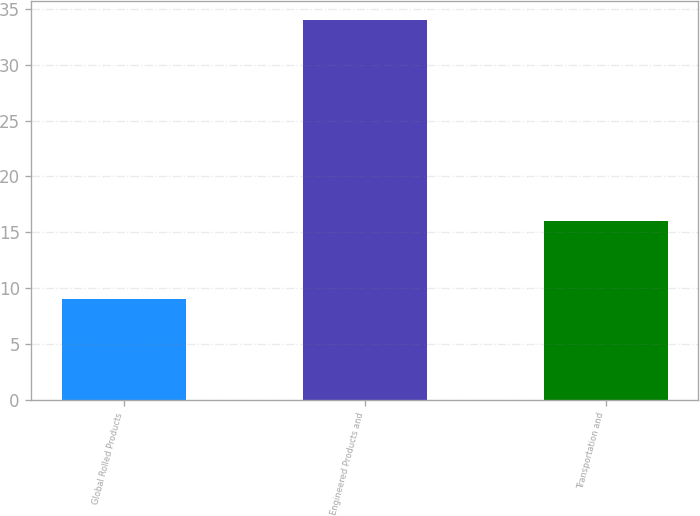Convert chart. <chart><loc_0><loc_0><loc_500><loc_500><bar_chart><fcel>Global Rolled Products<fcel>Engineered Products and<fcel>Transportation and<nl><fcel>9<fcel>34<fcel>16<nl></chart> 